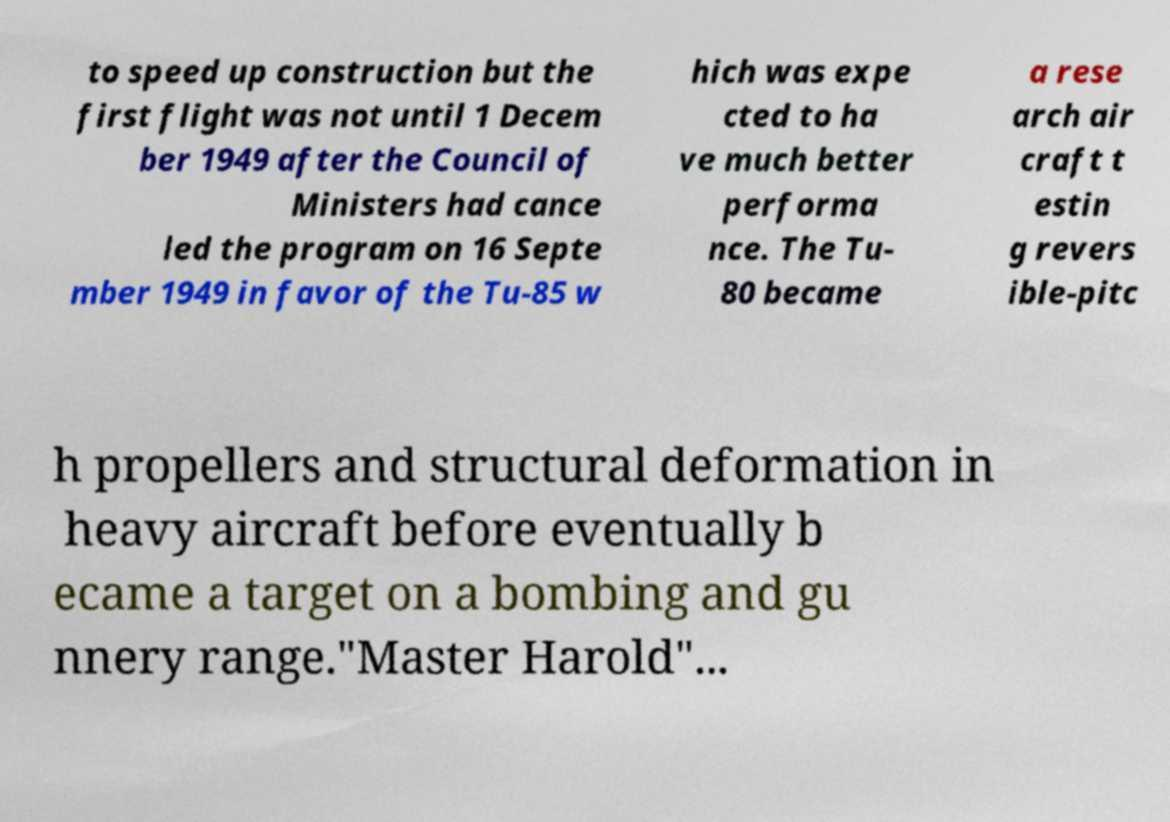There's text embedded in this image that I need extracted. Can you transcribe it verbatim? to speed up construction but the first flight was not until 1 Decem ber 1949 after the Council of Ministers had cance led the program on 16 Septe mber 1949 in favor of the Tu-85 w hich was expe cted to ha ve much better performa nce. The Tu- 80 became a rese arch air craft t estin g revers ible-pitc h propellers and structural deformation in heavy aircraft before eventually b ecame a target on a bombing and gu nnery range."Master Harold"... 